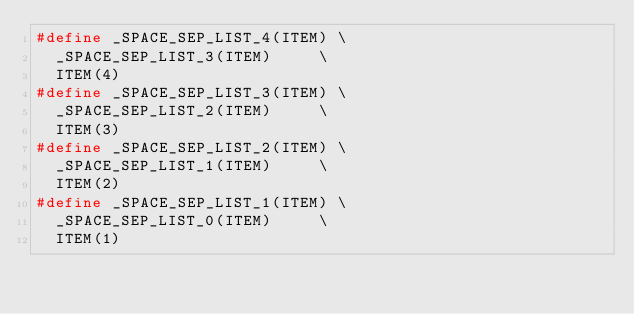<code> <loc_0><loc_0><loc_500><loc_500><_C_>#define _SPACE_SEP_LIST_4(ITEM) \
	_SPACE_SEP_LIST_3(ITEM)     \
	ITEM(4)
#define _SPACE_SEP_LIST_3(ITEM) \
	_SPACE_SEP_LIST_2(ITEM)     \
	ITEM(3)
#define _SPACE_SEP_LIST_2(ITEM) \
	_SPACE_SEP_LIST_1(ITEM)     \
	ITEM(2)
#define _SPACE_SEP_LIST_1(ITEM) \
	_SPACE_SEP_LIST_0(ITEM)     \
	ITEM(1)</code> 